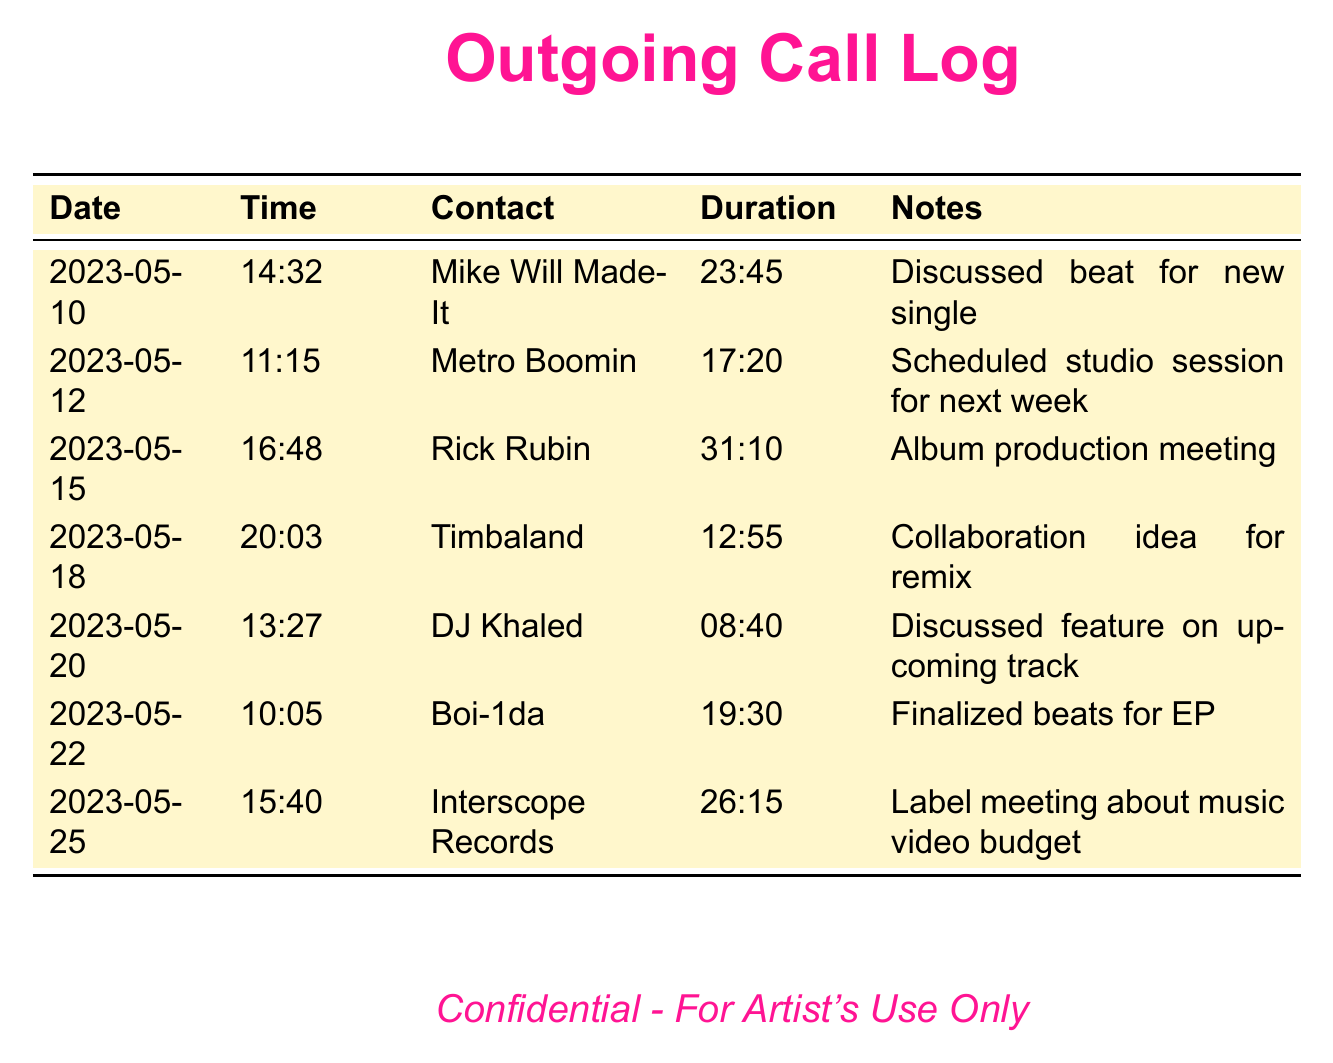what is the date of the call with Mike Will Made-It? The call with Mike Will Made-It took place on May 10, 2023.
Answer: 2023-05-10 what was the duration of the call with Rick Rubin? The call with Rick Rubin lasted for 31 minutes and 10 seconds.
Answer: 31:10 who was discussed for a collaboration remix idea? The collaboration idea for a remix was discussed with Timbaland.
Answer: Timbaland how many calls were made to Interscope Records? There is one call recorded for Interscope Records in the log.
Answer: 1 what type of meeting was held on May 25? The meeting held on May 25 was about the music video budget.
Answer: Label meeting which producer was contacted for finalizing beats for an EP? The beats for the EP were finalized with Boi-1da.
Answer: Boi-1da how many total minutes of calls were logged in this document? The total duration of the calls can be calculated by adding up each call's duration listed.
Answer: 119:55 which contact had the longest call duration? The longest call duration was with Rick Rubin.
Answer: Rick Rubin what was discussed during the call with DJ Khaled? The discussion during the call with DJ Khaled was about a feature on an upcoming track.
Answer: Feature on upcoming track 